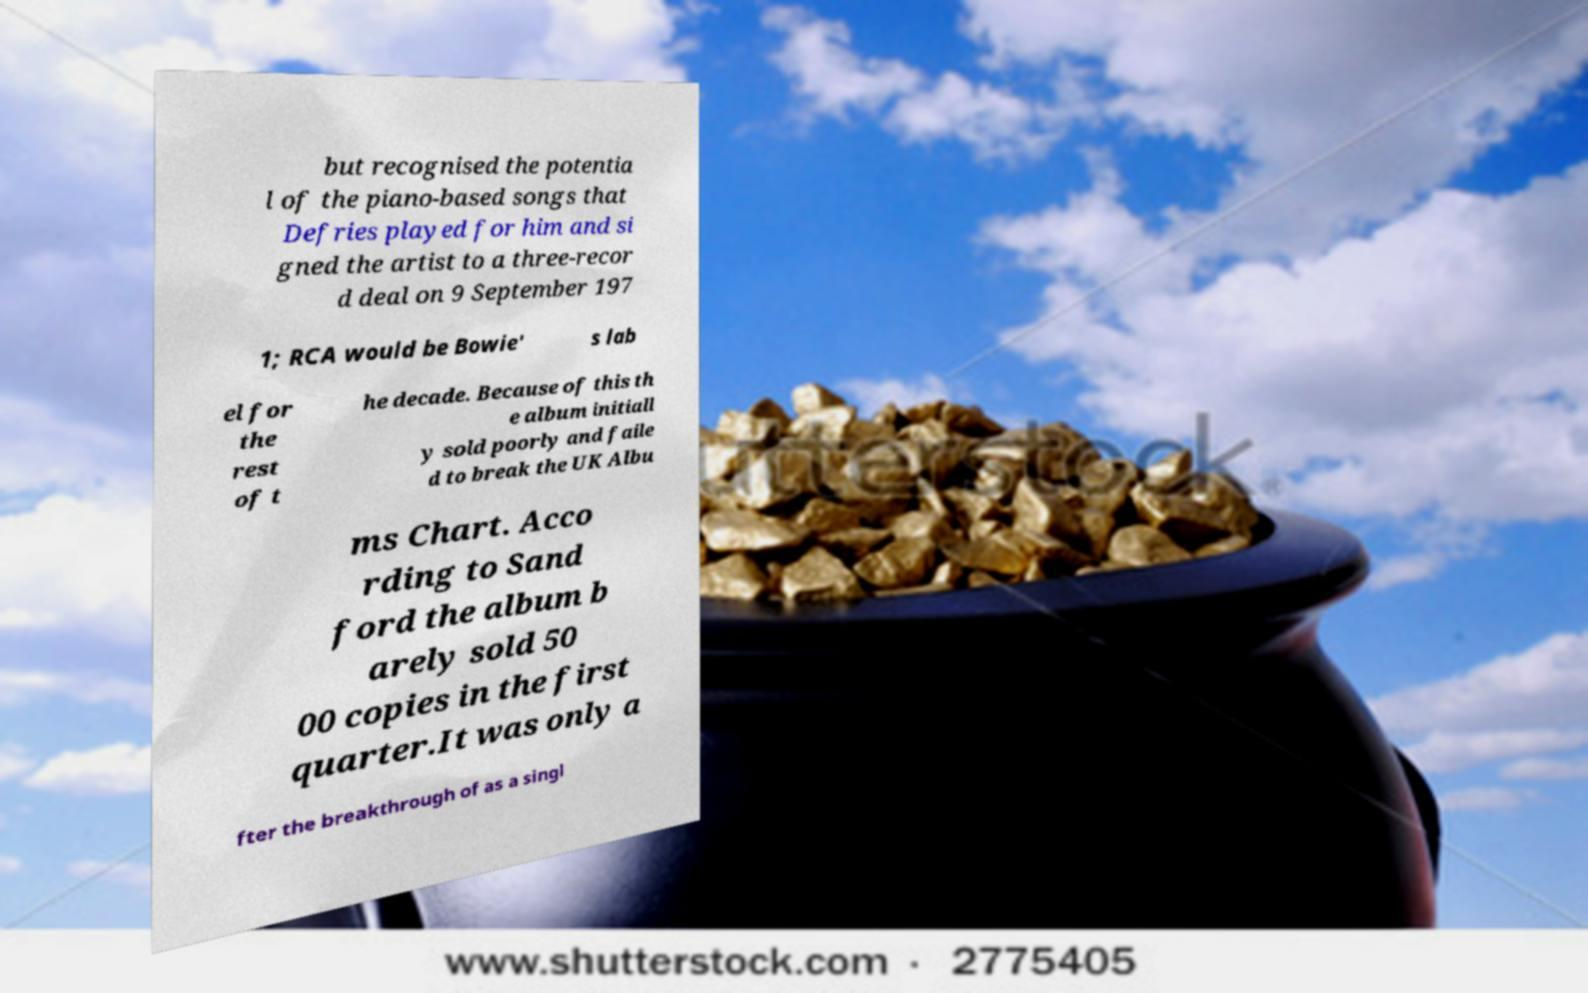Could you assist in decoding the text presented in this image and type it out clearly? but recognised the potentia l of the piano-based songs that Defries played for him and si gned the artist to a three-recor d deal on 9 September 197 1; RCA would be Bowie' s lab el for the rest of t he decade. Because of this th e album initiall y sold poorly and faile d to break the UK Albu ms Chart. Acco rding to Sand ford the album b arely sold 50 00 copies in the first quarter.It was only a fter the breakthrough of as a singl 